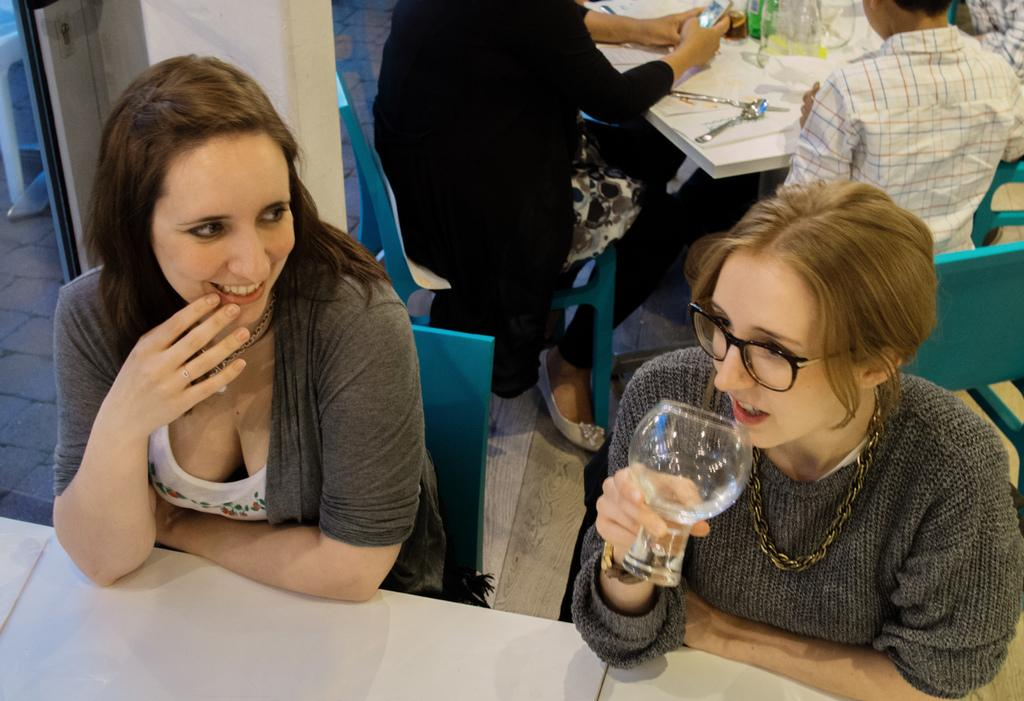What are the people in the image doing? The people in the image are sitting on chairs. Can you describe the woman in the image? The woman in the image is holding a glass. What type of furniture is present in the image? There are tables in the image. What can be seen on the floor in the image? The floor is visible in the image. What is on the table in the image? There are objects on the table in the image. What type of oil can be seen dripping from the bag in the image? There is no bag or oil present in the image. 